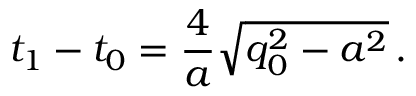Convert formula to latex. <formula><loc_0><loc_0><loc_500><loc_500>t _ { 1 } - t _ { 0 } = { \frac { 4 } { a } } \sqrt { q _ { 0 } ^ { 2 } - a ^ { 2 } } \, .</formula> 